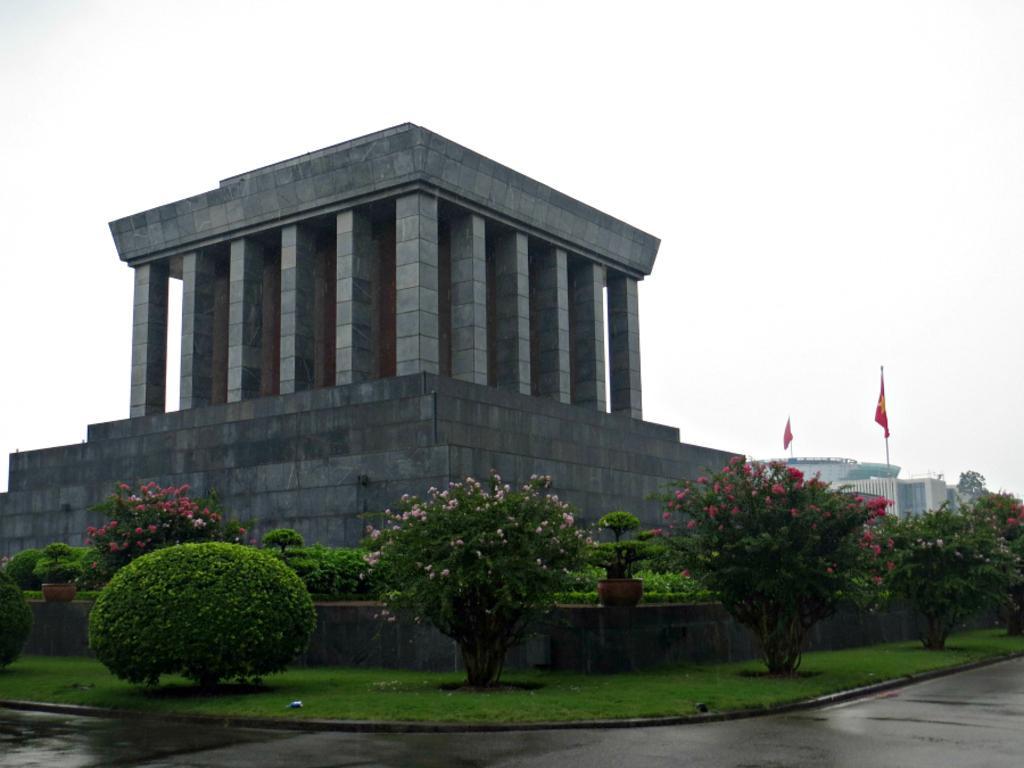Please provide a concise description of this image. Here we can see a roof and pillars. In-front of this wall there are plants. To these plants there are flowers. Far there is a building. Above this building there are flags. 